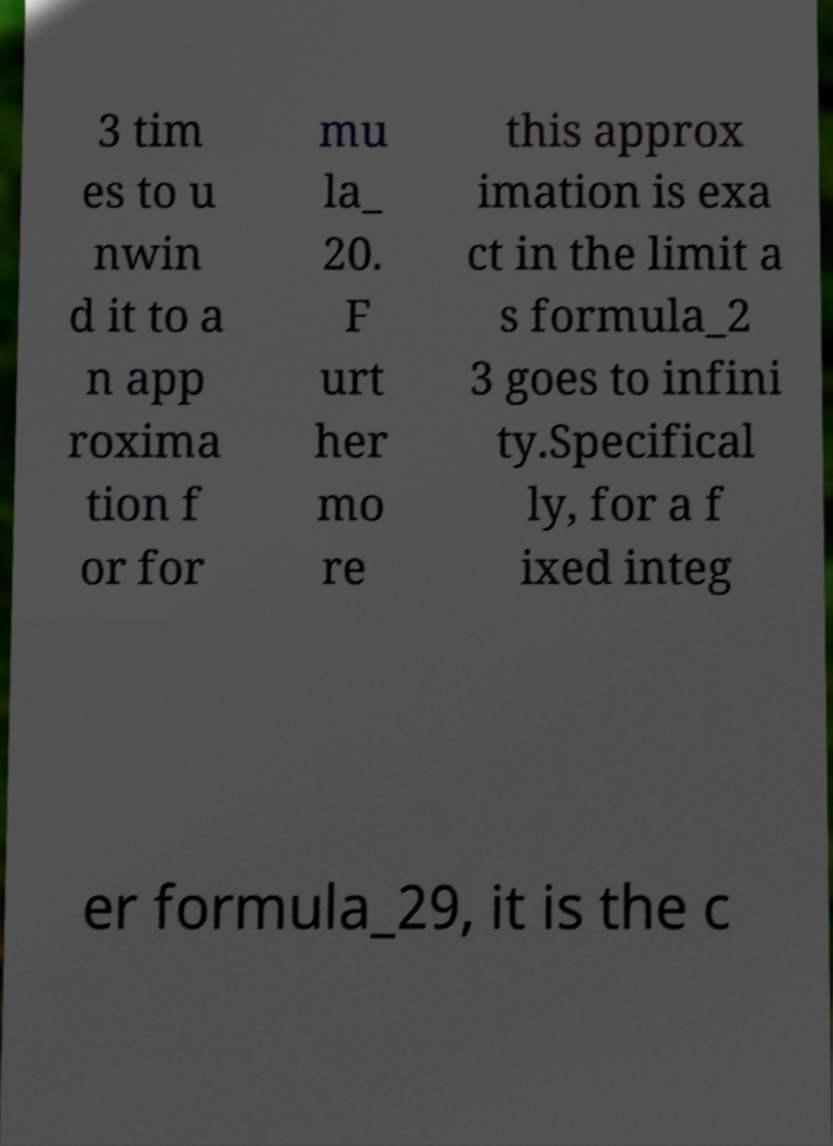What messages or text are displayed in this image? I need them in a readable, typed format. 3 tim es to u nwin d it to a n app roxima tion f or for mu la_ 20. F urt her mo re this approx imation is exa ct in the limit a s formula_2 3 goes to infini ty.Specifical ly, for a f ixed integ er formula_29, it is the c 